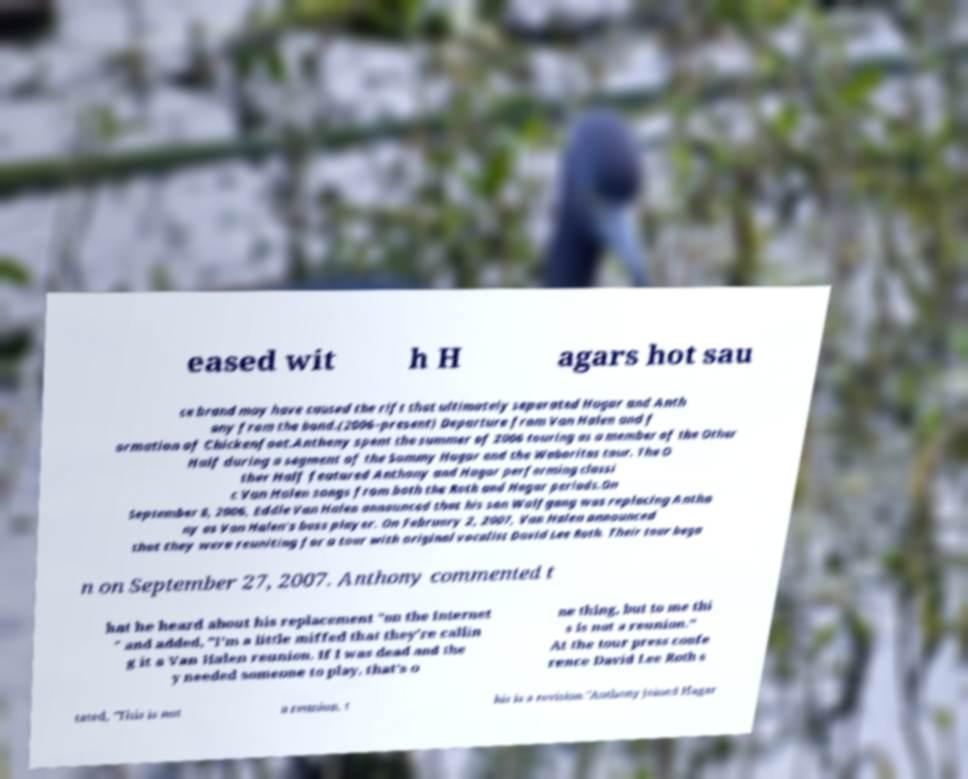There's text embedded in this image that I need extracted. Can you transcribe it verbatim? eased wit h H agars hot sau ce brand may have caused the rift that ultimately separated Hagar and Anth ony from the band.(2006–present) Departure from Van Halen and f ormation of Chickenfoot.Anthony spent the summer of 2006 touring as a member of the Other Half during a segment of the Sammy Hagar and the Waboritas tour. The O ther Half featured Anthony and Hagar performing classi c Van Halen songs from both the Roth and Hagar periods.On September 8, 2006, Eddie Van Halen announced that his son Wolfgang was replacing Antho ny as Van Halen's bass player. On February 2, 2007, Van Halen announced that they were reuniting for a tour with original vocalist David Lee Roth. Their tour bega n on September 27, 2007. Anthony commented t hat he heard about his replacement "on the Internet " and added, "I'm a little miffed that they're callin g it a Van Halen reunion. If I was dead and the y needed someone to play, that's o ne thing, but to me thi s is not a reunion." At the tour press confe rence David Lee Roth s tated, "This is not a reunion, t his is a revision."Anthony joined Hagar 